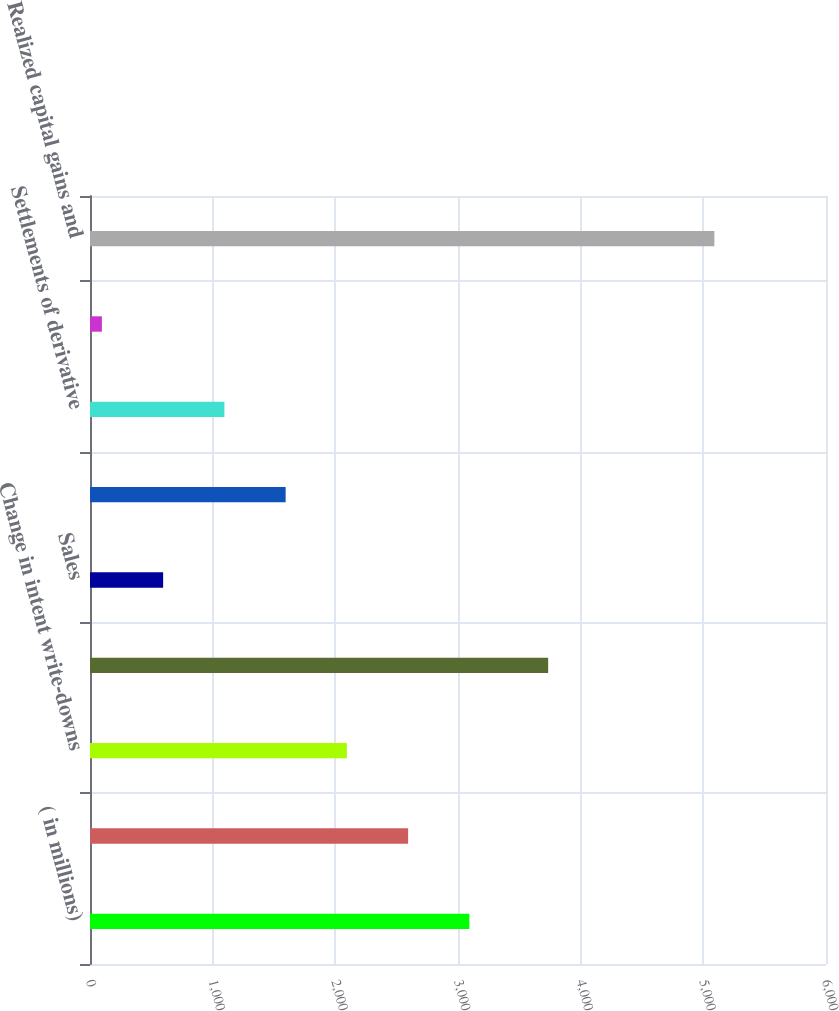Convert chart. <chart><loc_0><loc_0><loc_500><loc_500><bar_chart><fcel>( in millions)<fcel>Impairment write-downs<fcel>Change in intent write-downs<fcel>Net other-than-temporary<fcel>Sales<fcel>Valuation of derivative<fcel>Settlements of derivative<fcel>EMA limited partnership income<fcel>Realized capital gains and<nl><fcel>3092.8<fcel>2593.5<fcel>2094.2<fcel>3735<fcel>596.3<fcel>1594.9<fcel>1095.6<fcel>97<fcel>5090<nl></chart> 